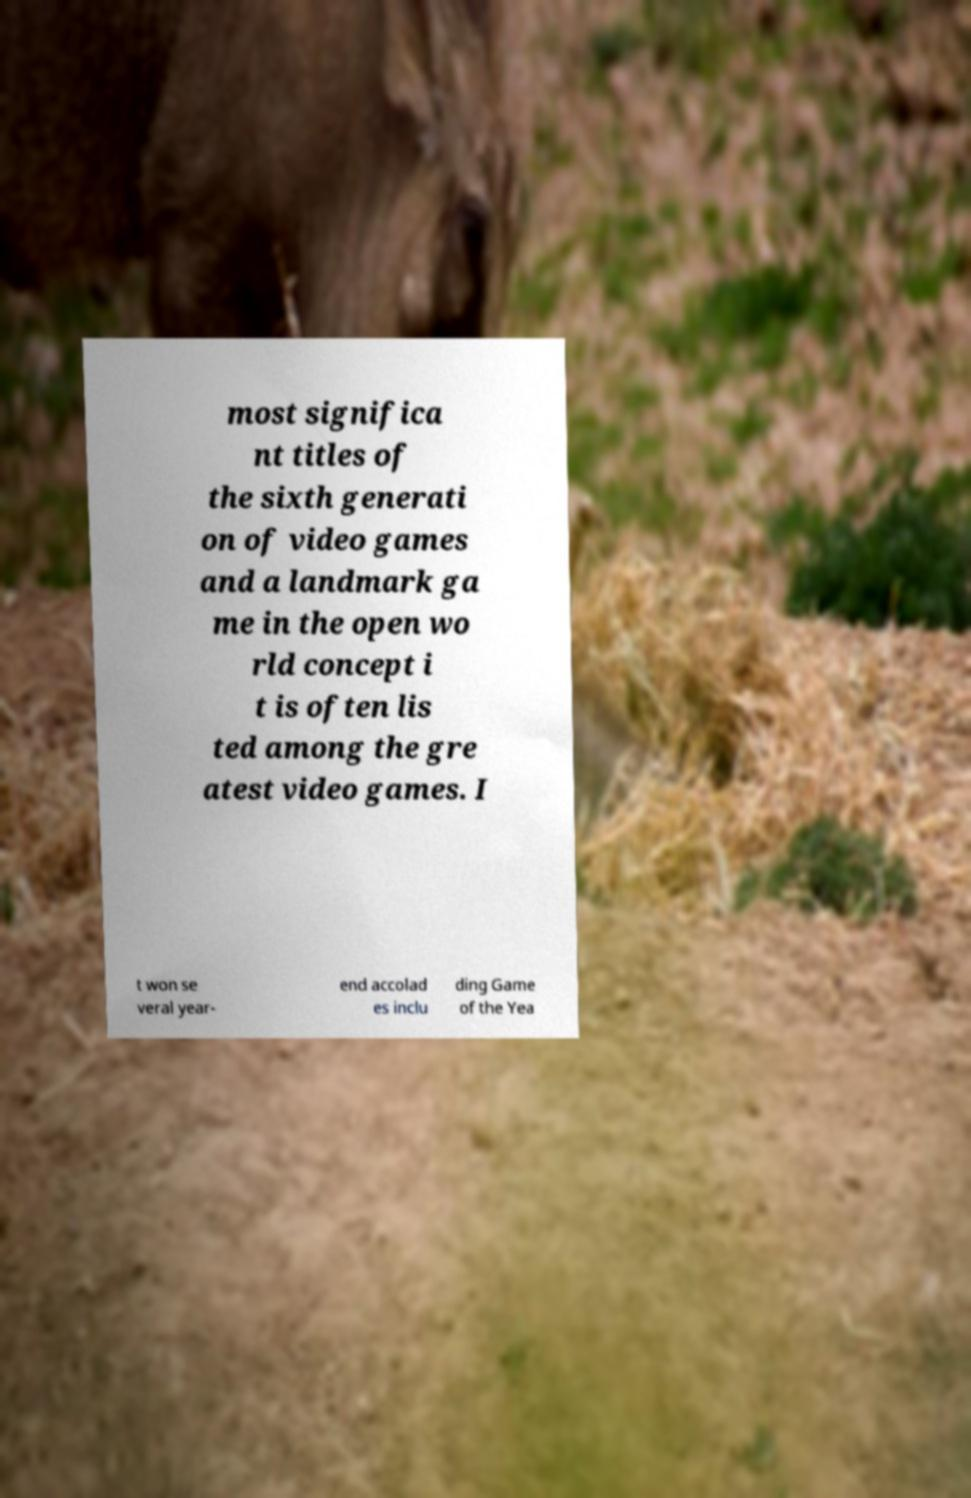Please identify and transcribe the text found in this image. most significa nt titles of the sixth generati on of video games and a landmark ga me in the open wo rld concept i t is often lis ted among the gre atest video games. I t won se veral year- end accolad es inclu ding Game of the Yea 